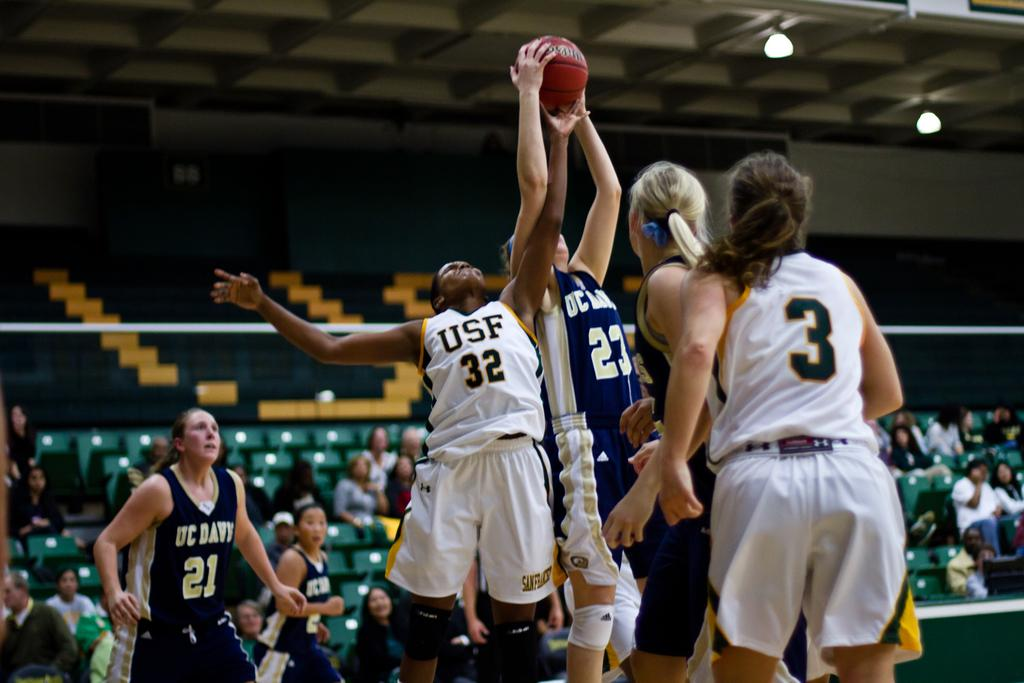<image>
Relay a brief, clear account of the picture shown. The player from USF goes up for the jumpball at the basketball game. 